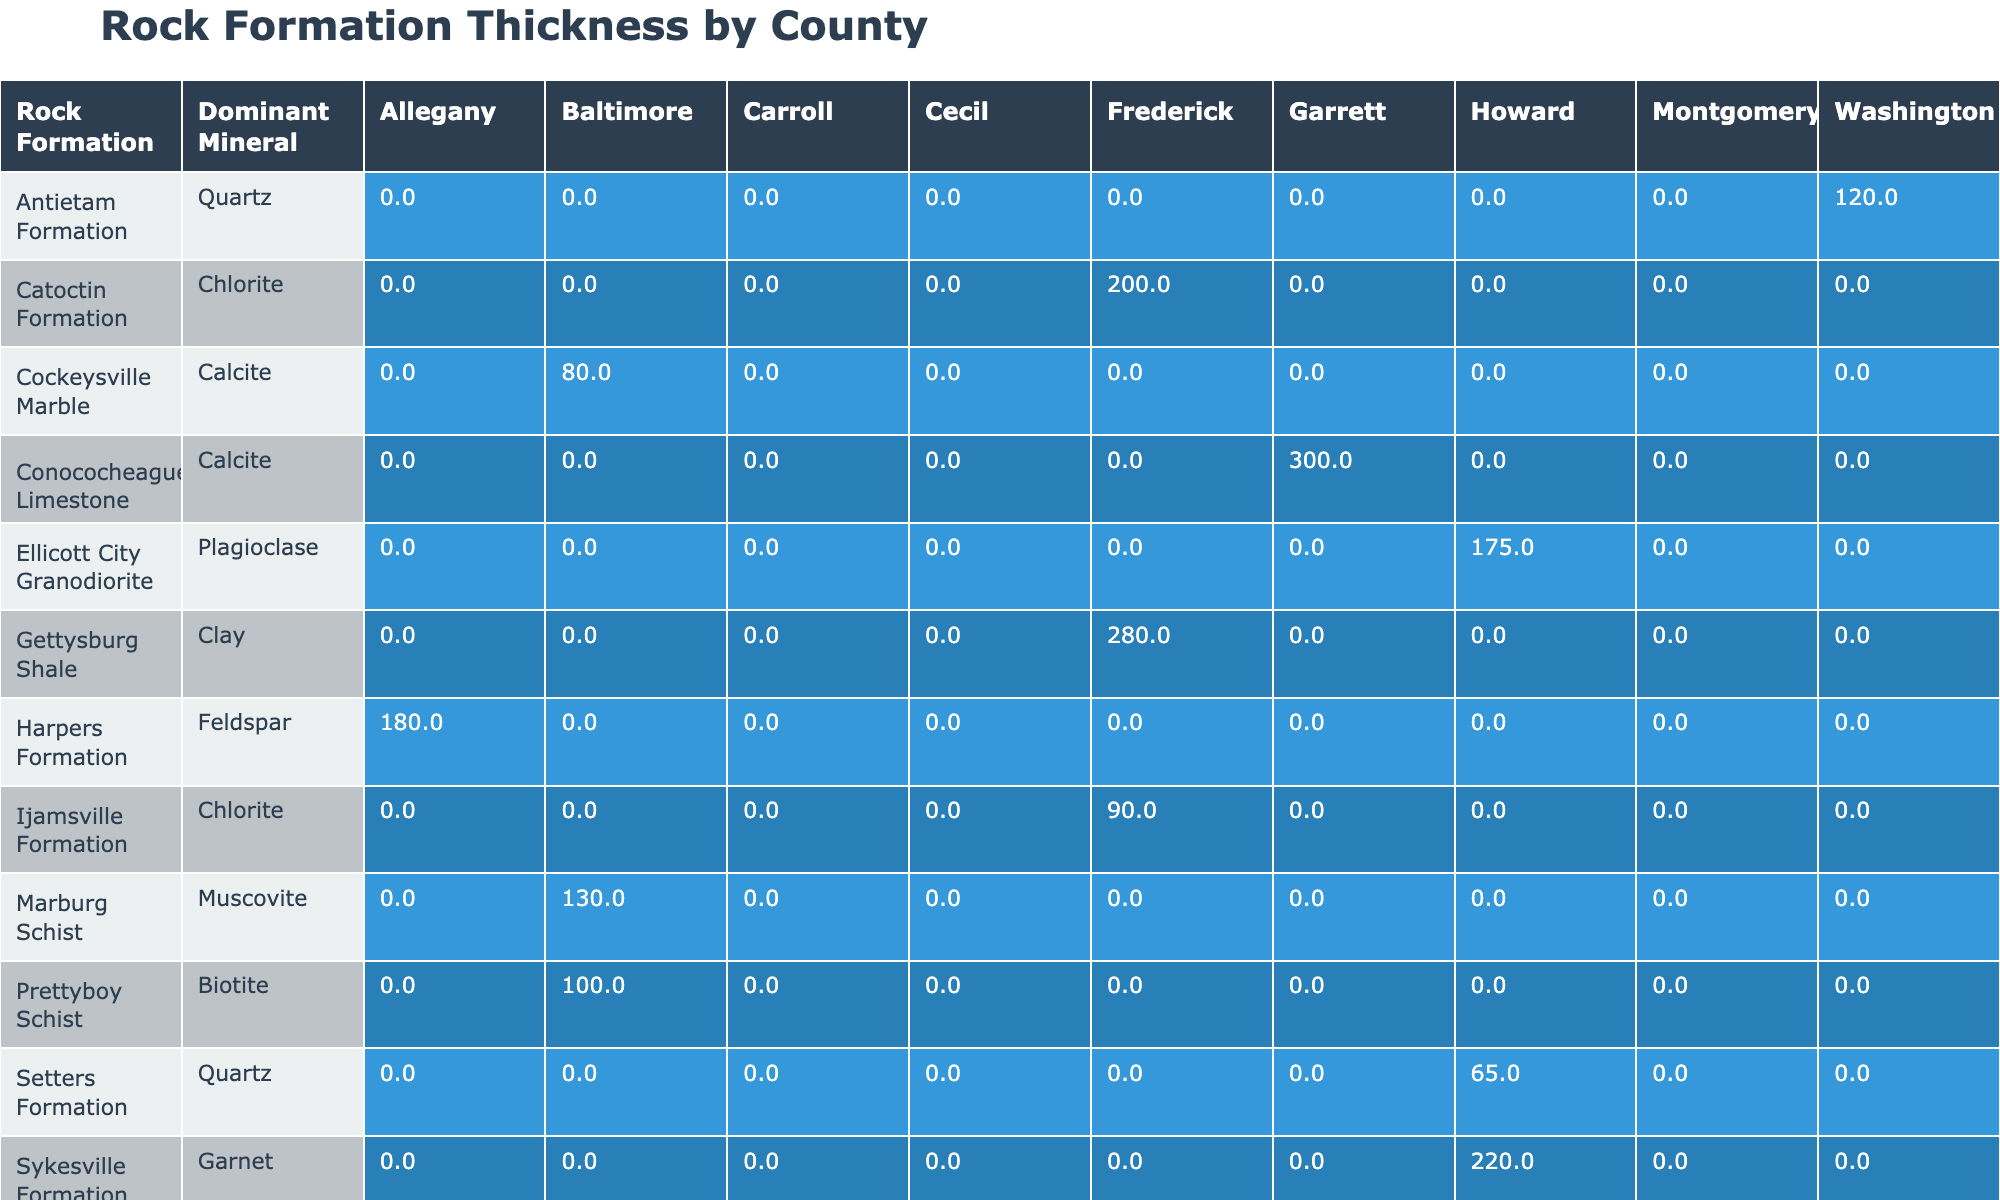What is the dominant mineral in the Catoctin Formation? The Catoctin Formation is listed in the table under the "Rock Formation" category along with its corresponding "Dominant Mineral" column. According to the table, the dominant mineral for the Catoctin Formation is Chlorite.
Answer: Chlorite Which formation has the greatest thickness of rock in Baltimore County? In the Baltimore County section of the table, we look at the thickness values for each rock formation: 80 m for Cockeysville Marble and 100 m for Prettyboy Schist. The greatest value is 100 m for Prettyboy Schist.
Answer: 100 m Is the thickness of the Waynesboro Formation greater than that of the Ijamsville Formation? From the table, the thickness of Waynesboro Formation is 250 m while Ijamsville Formation has a thickness of 90 m. Since 250 m is greater than 90 m, the statement is true.
Answer: Yes What is the average thickness of rock formations in Howard County? In Howard County, the relevant formations and their thicknesses are Sykesville Formation (220 m) and Ellicott City Granodiorite (175 m). We compute the average by summing the two thicknesses (220 + 175 = 395 m) and dividing by the number of formations (2), which gives us 395/2 = 197.5 m.
Answer: 197.5 m Which county has the highest recorded thickness for rock formations? To determine which county has the highest thickness, we should look at the maximum thickness values from each county: Baltimore (100 m), Howard (220 m), Frederick (280 m), etc. Among these, the highest thickness is found in Frederick County for the Gettysburg Shale at 280 m.
Answer: Frederick County What mineral is dominant in both the Antietam and Tomstown formations? We refer to the "Dominant Mineral" column from the table. Antietam Formation has Quartz, while Tomstown Dolomite has Dolomite. Therefore, the dominant minerals differ; there is no common mineral.
Answer: No common mineral Which formation is younger, the Sykesville Formation or the Cockeysville Marble, and what is the age difference? From the table, Sykesville Formation is 470 million years old, while Cockeysville Marble is 450 million years old. Hence, Cockeysville is younger, and the age difference is calculated as 470 - 450 = 20 million years.
Answer: Sykesville Formation is younger; age difference: 20 million years Are there any formations in the table that were sampled in 2022? Checking the "Sample Date" column, we see that several formations were sampled in 2022: Cockeysville Marble, Wissahickon Formation, Setters Formation, Antietam Formation, Harpers Formation, Conococheague Limestone, and Waynesboro Formation. Therefore, the answer is yes.
Answer: Yes 